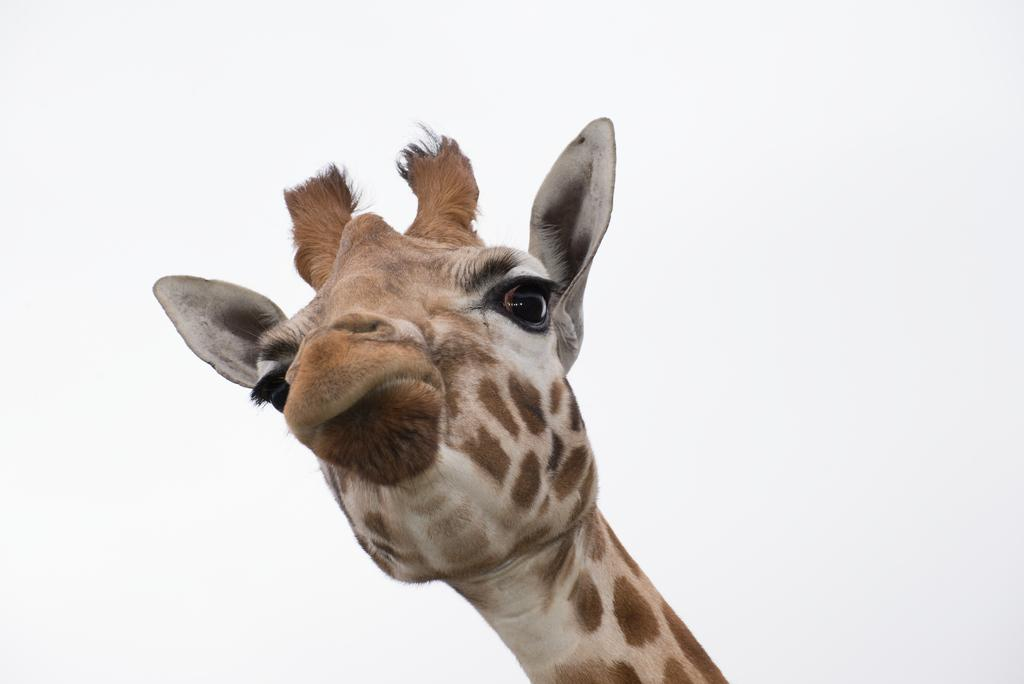Where was the image taken? The image was clicked outside. What is the main subject of the image? The center of the image features a giraffe. What specific features of the giraffe can be seen in the image? The giraffe's horns, ears, eyes, mouth, and neck are visible in the image. What can be seen in the background of the image? The sky is visible in the background of the image. What type of cushion is being used by the giraffe's toe in the image? There is no cushion or toe present in the image, as it features a giraffe in its natural environment. 